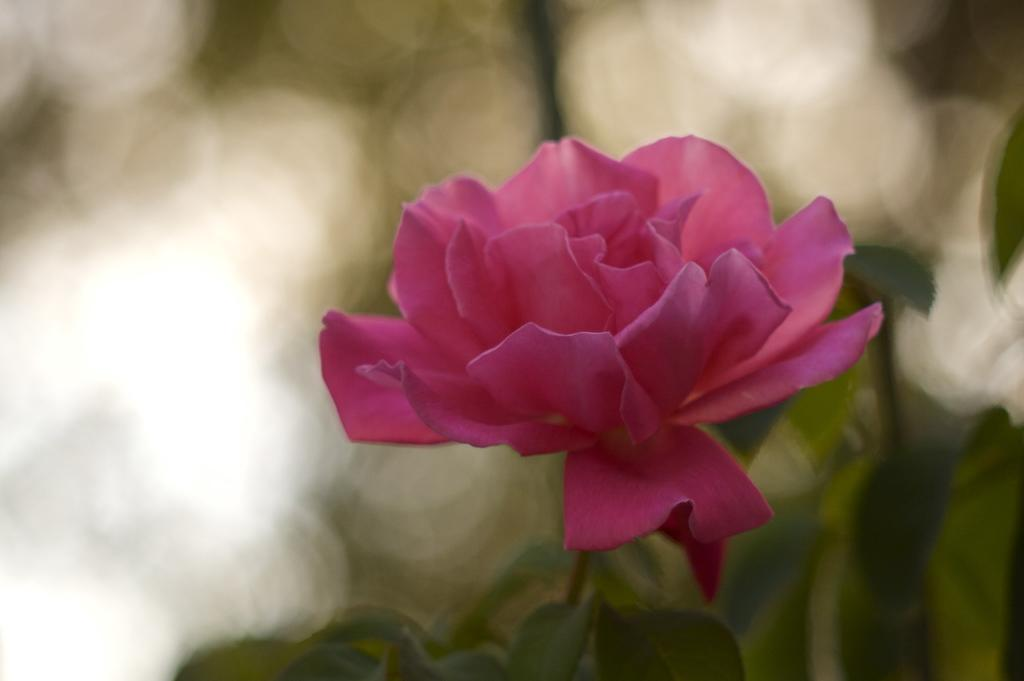What is the main subject of the image? There is a flower in the image. How many rabbits can be seen playing on the railway near the flower in the image? There are no rabbits or railway present in the image; it only features a flower. 